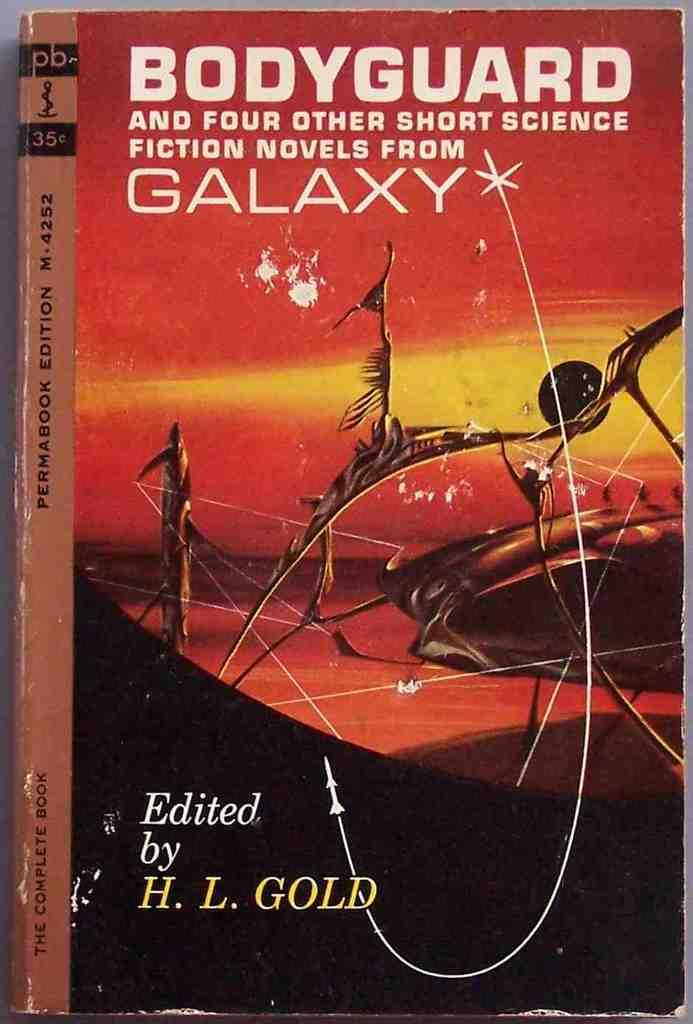Provide a one-sentence caption for the provided image. A paperback science fiction book titled Bodyguard and Four Other Short Science Fiction Novels from Galaxy. 